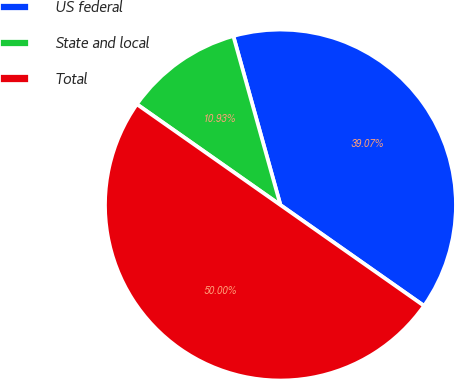Convert chart. <chart><loc_0><loc_0><loc_500><loc_500><pie_chart><fcel>US federal<fcel>State and local<fcel>Total<nl><fcel>39.07%<fcel>10.93%<fcel>50.0%<nl></chart> 